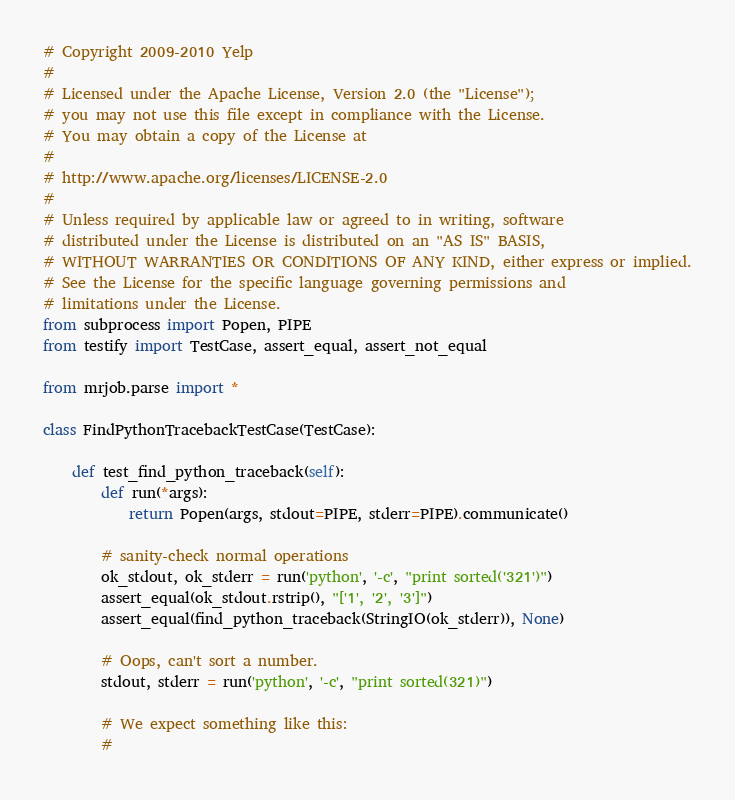<code> <loc_0><loc_0><loc_500><loc_500><_Python_># Copyright 2009-2010 Yelp
#
# Licensed under the Apache License, Version 2.0 (the "License");
# you may not use this file except in compliance with the License.
# You may obtain a copy of the License at
#
# http://www.apache.org/licenses/LICENSE-2.0
#
# Unless required by applicable law or agreed to in writing, software
# distributed under the License is distributed on an "AS IS" BASIS,
# WITHOUT WARRANTIES OR CONDITIONS OF ANY KIND, either express or implied.
# See the License for the specific language governing permissions and
# limitations under the License.
from subprocess import Popen, PIPE
from testify import TestCase, assert_equal, assert_not_equal

from mrjob.parse import *

class FindPythonTracebackTestCase(TestCase):

    def test_find_python_traceback(self):
        def run(*args):
            return Popen(args, stdout=PIPE, stderr=PIPE).communicate()

        # sanity-check normal operations
        ok_stdout, ok_stderr = run('python', '-c', "print sorted('321')")
        assert_equal(ok_stdout.rstrip(), "['1', '2', '3']")
        assert_equal(find_python_traceback(StringIO(ok_stderr)), None)

        # Oops, can't sort a number.
        stdout, stderr = run('python', '-c', "print sorted(321)")

        # We expect something like this:
        #</code> 